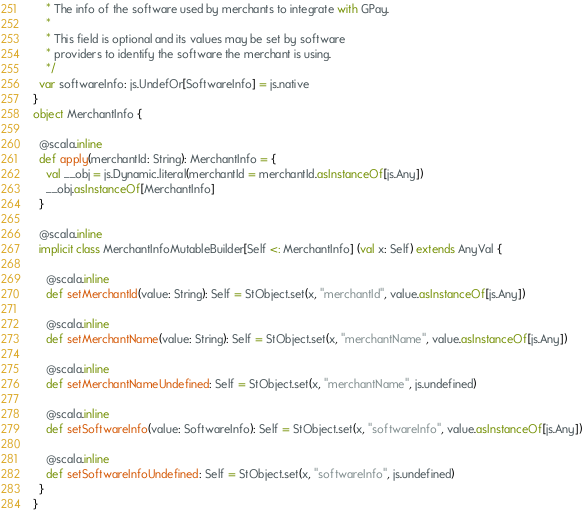Convert code to text. <code><loc_0><loc_0><loc_500><loc_500><_Scala_>    * The info of the software used by merchants to integrate with GPay.
    *
    * This field is optional and its values may be set by software
    * providers to identify the software the merchant is using.
    */
  var softwareInfo: js.UndefOr[SoftwareInfo] = js.native
}
object MerchantInfo {
  
  @scala.inline
  def apply(merchantId: String): MerchantInfo = {
    val __obj = js.Dynamic.literal(merchantId = merchantId.asInstanceOf[js.Any])
    __obj.asInstanceOf[MerchantInfo]
  }
  
  @scala.inline
  implicit class MerchantInfoMutableBuilder[Self <: MerchantInfo] (val x: Self) extends AnyVal {
    
    @scala.inline
    def setMerchantId(value: String): Self = StObject.set(x, "merchantId", value.asInstanceOf[js.Any])
    
    @scala.inline
    def setMerchantName(value: String): Self = StObject.set(x, "merchantName", value.asInstanceOf[js.Any])
    
    @scala.inline
    def setMerchantNameUndefined: Self = StObject.set(x, "merchantName", js.undefined)
    
    @scala.inline
    def setSoftwareInfo(value: SoftwareInfo): Self = StObject.set(x, "softwareInfo", value.asInstanceOf[js.Any])
    
    @scala.inline
    def setSoftwareInfoUndefined: Self = StObject.set(x, "softwareInfo", js.undefined)
  }
}
</code> 